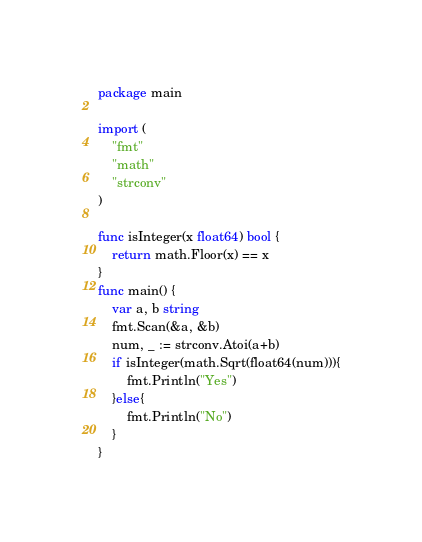<code> <loc_0><loc_0><loc_500><loc_500><_Go_>package main

import (
	"fmt"
	"math"
	"strconv"
)

func isInteger(x float64) bool {
	return math.Floor(x) == x
}
func main() {
	var a, b string
	fmt.Scan(&a, &b)
	num, _ := strconv.Atoi(a+b)
	if isInteger(math.Sqrt(float64(num))){
		fmt.Println("Yes")
	}else{
		fmt.Println("No")
	}
}</code> 